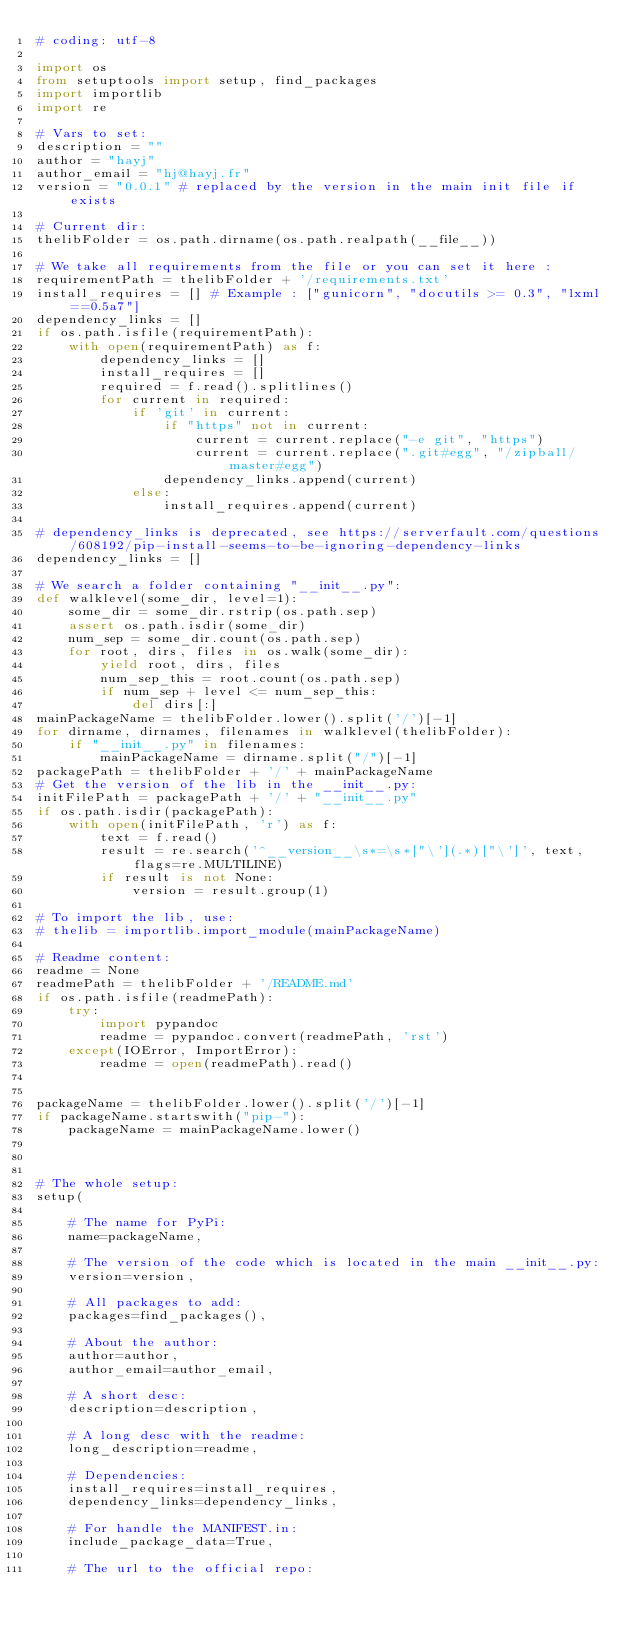Convert code to text. <code><loc_0><loc_0><loc_500><loc_500><_Python_># coding: utf-8

import os
from setuptools import setup, find_packages
import importlib
import re

# Vars to set:
description = ""
author = "hayj"
author_email = "hj@hayj.fr"
version = "0.0.1" # replaced by the version in the main init file if exists

# Current dir:
thelibFolder = os.path.dirname(os.path.realpath(__file__))

# We take all requirements from the file or you can set it here :
requirementPath = thelibFolder + '/requirements.txt'
install_requires = [] # Example : ["gunicorn", "docutils >= 0.3", "lxml==0.5a7"]
dependency_links = []
if os.path.isfile(requirementPath):
    with open(requirementPath) as f:
        dependency_links = []
        install_requires = []
        required = f.read().splitlines()
        for current in required:
            if 'git' in current:
                if "https" not in current:
                    current = current.replace("-e git", "https")
                    current = current.replace(".git#egg", "/zipball/master#egg")
                dependency_links.append(current)
            else:
                install_requires.append(current)

# dependency_links is deprecated, see https://serverfault.com/questions/608192/pip-install-seems-to-be-ignoring-dependency-links
dependency_links = []

# We search a folder containing "__init__.py":
def walklevel(some_dir, level=1):
    some_dir = some_dir.rstrip(os.path.sep)
    assert os.path.isdir(some_dir)
    num_sep = some_dir.count(os.path.sep)
    for root, dirs, files in os.walk(some_dir):
        yield root, dirs, files
        num_sep_this = root.count(os.path.sep)
        if num_sep + level <= num_sep_this:
            del dirs[:]
mainPackageName = thelibFolder.lower().split('/')[-1]
for dirname, dirnames, filenames in walklevel(thelibFolder):
    if "__init__.py" in filenames:
        mainPackageName = dirname.split("/")[-1]
packagePath = thelibFolder + '/' + mainPackageName
# Get the version of the lib in the __init__.py:
initFilePath = packagePath + '/' + "__init__.py"
if os.path.isdir(packagePath):
    with open(initFilePath, 'r') as f:
        text = f.read()
        result = re.search('^__version__\s*=\s*["\'](.*)["\']', text, flags=re.MULTILINE)
        if result is not None:
            version = result.group(1)

# To import the lib, use:
# thelib = importlib.import_module(mainPackageName)

# Readme content:
readme = None
readmePath = thelibFolder + '/README.md'
if os.path.isfile(readmePath):
    try:
        import pypandoc
        readme = pypandoc.convert(readmePath, 'rst')
    except(IOError, ImportError):
        readme = open(readmePath).read()


packageName = thelibFolder.lower().split('/')[-1]  
if packageName.startswith("pip-"):
    packageName = mainPackageName.lower()



# The whole setup:
setup(

    # The name for PyPi:
    name=packageName,

    # The version of the code which is located in the main __init__.py:
    version=version,

    # All packages to add:
    packages=find_packages(),

    # About the author:
    author=author,
    author_email=author_email,

    # A short desc:
    description=description,

    # A long desc with the readme:
    long_description=readme,

    # Dependencies:
    install_requires=install_requires,
    dependency_links=dependency_links,
    
    # For handle the MANIFEST.in:
    include_package_data=True,

    # The url to the official repo:</code> 